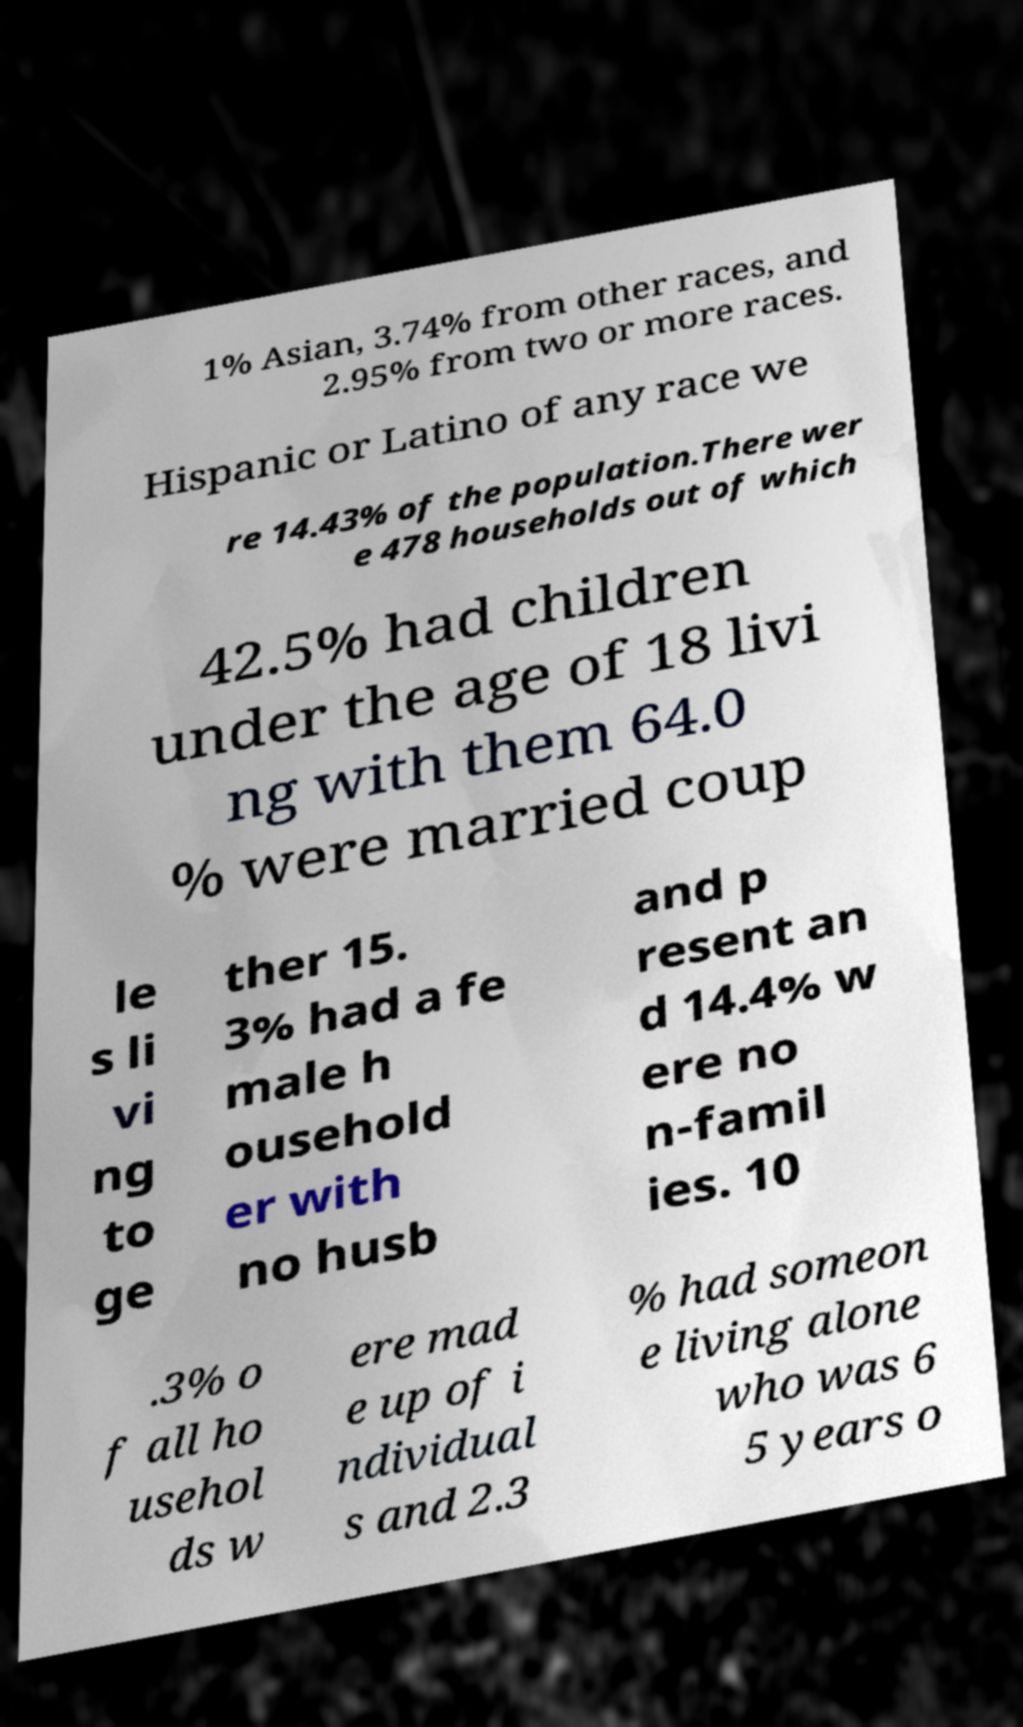I need the written content from this picture converted into text. Can you do that? 1% Asian, 3.74% from other races, and 2.95% from two or more races. Hispanic or Latino of any race we re 14.43% of the population.There wer e 478 households out of which 42.5% had children under the age of 18 livi ng with them 64.0 % were married coup le s li vi ng to ge ther 15. 3% had a fe male h ousehold er with no husb and p resent an d 14.4% w ere no n-famil ies. 10 .3% o f all ho usehol ds w ere mad e up of i ndividual s and 2.3 % had someon e living alone who was 6 5 years o 